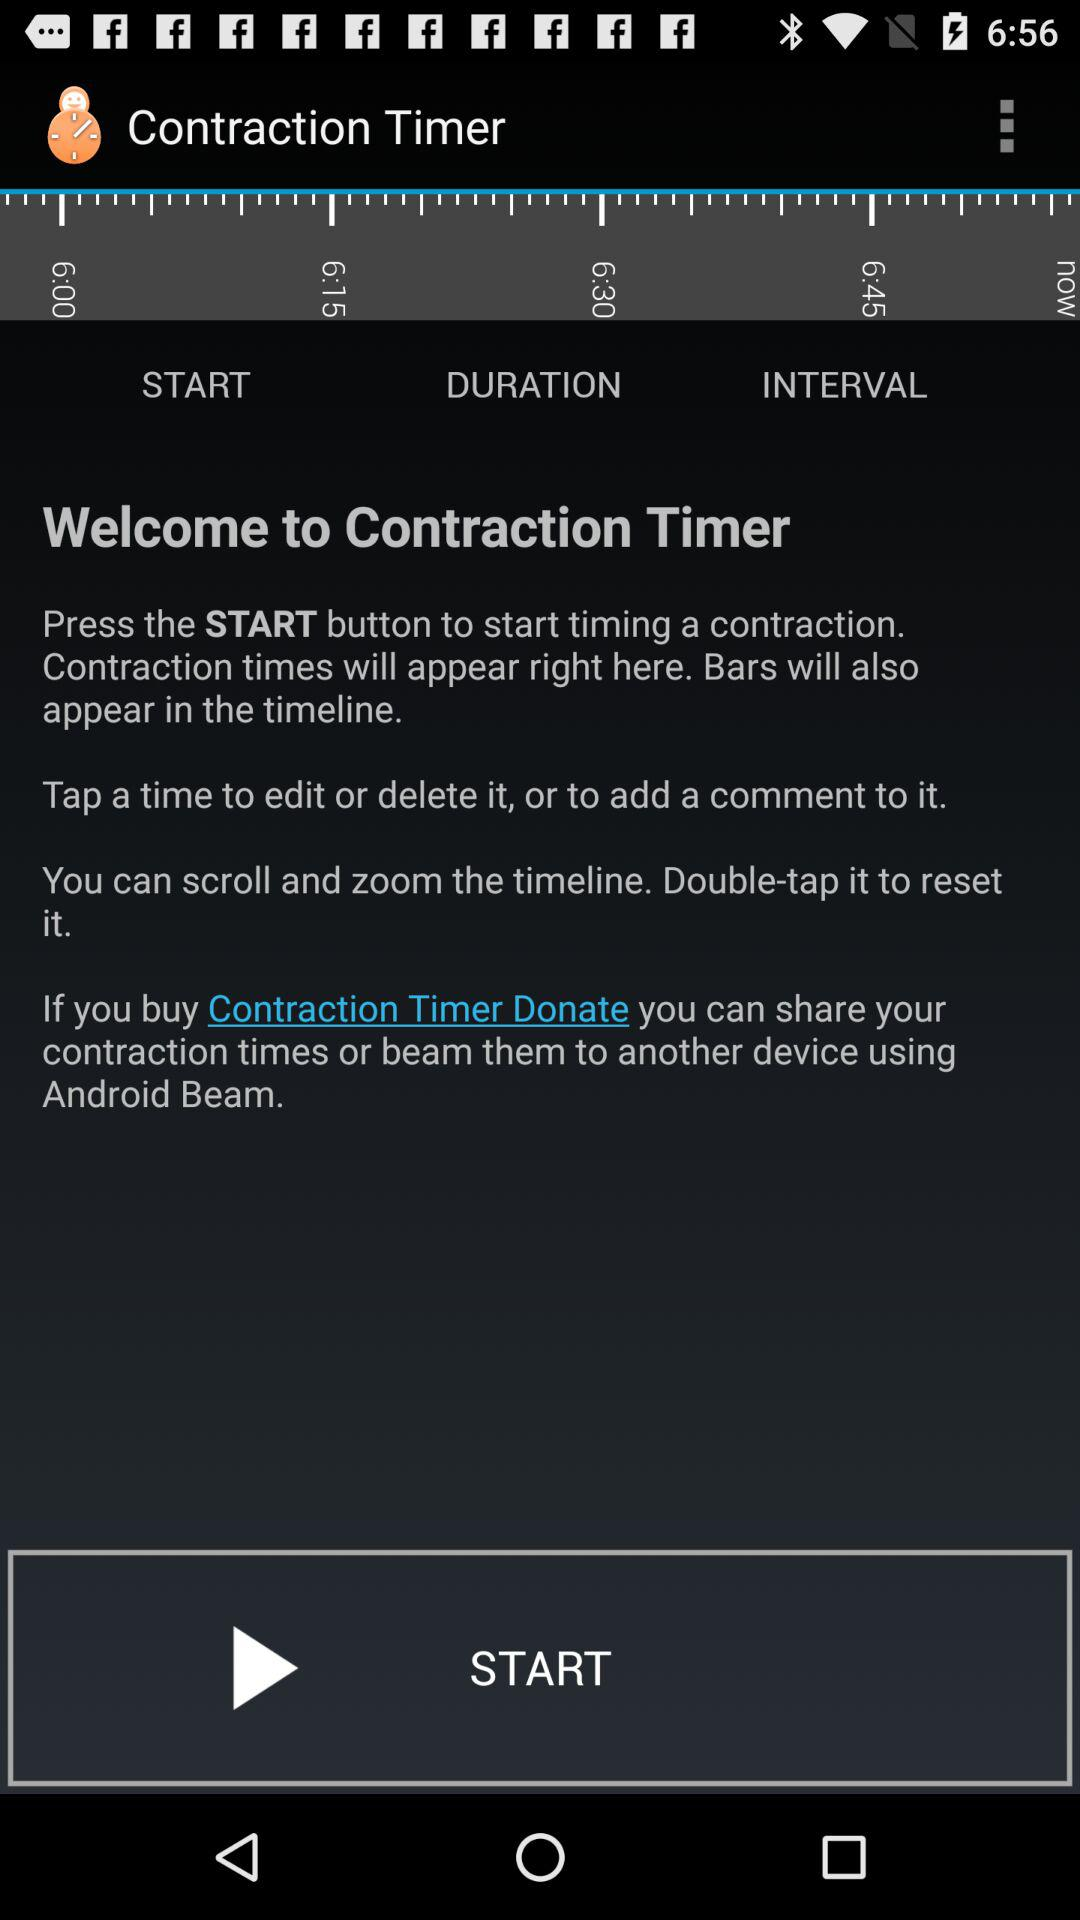What is the name of the application? The name of the application is "Contraction Timer". 